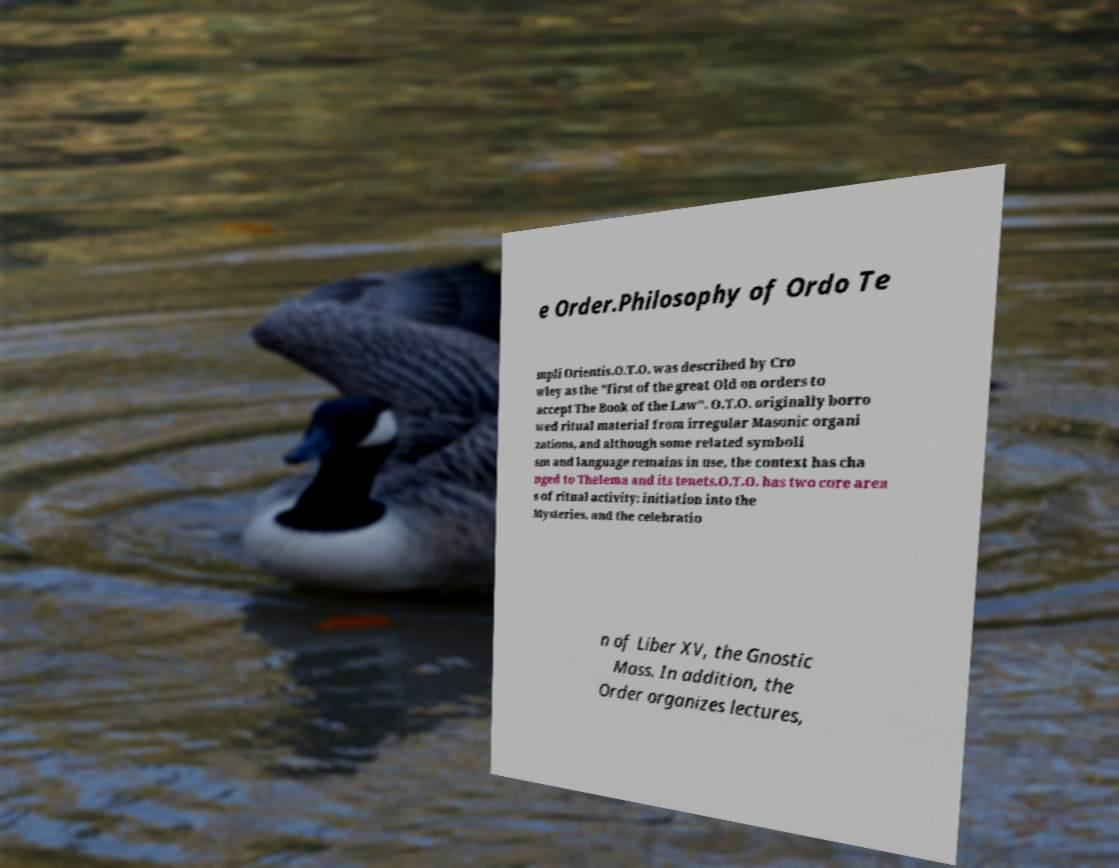For documentation purposes, I need the text within this image transcribed. Could you provide that? e Order.Philosophy of Ordo Te mpli Orientis.O.T.O. was described by Cro wley as the "first of the great Old on orders to accept The Book of the Law". O.T.O. originally borro wed ritual material from irregular Masonic organi zations, and although some related symboli sm and language remains in use, the context has cha nged to Thelema and its tenets.O.T.O. has two core area s of ritual activity: initiation into the Mysteries, and the celebratio n of Liber XV, the Gnostic Mass. In addition, the Order organizes lectures, 